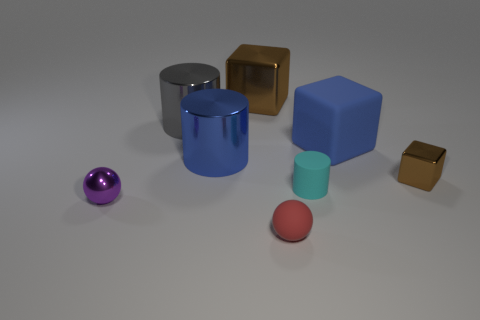Add 1 large blue rubber objects. How many objects exist? 9 Subtract all balls. How many objects are left? 6 Subtract all small cyan matte cylinders. Subtract all large blue objects. How many objects are left? 5 Add 2 blue things. How many blue things are left? 4 Add 1 blue blocks. How many blue blocks exist? 2 Subtract 0 yellow balls. How many objects are left? 8 